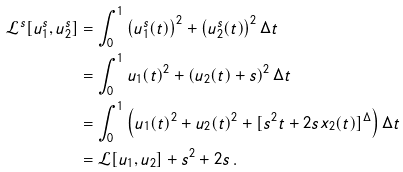<formula> <loc_0><loc_0><loc_500><loc_500>\mathcal { L } ^ { s } [ u _ { 1 } ^ { s } , u _ { 2 } ^ { s } ] & = \int _ { 0 } ^ { 1 } \left ( u _ { 1 } ^ { s } ( t ) \right ) ^ { 2 } + \left ( u _ { 2 } ^ { s } ( t ) \right ) ^ { 2 } \Delta t \\ & = \int _ { 0 } ^ { 1 } u _ { 1 } ( t ) ^ { 2 } + \left ( u _ { 2 } ( t ) + s \right ) ^ { 2 } \Delta t \\ & = \int _ { 0 } ^ { 1 } \left ( u _ { 1 } ( t ) ^ { 2 } + u _ { 2 } ( t ) ^ { 2 } + [ s ^ { 2 } t + 2 s x _ { 2 } ( t ) ] ^ { \Delta } \right ) \Delta t \\ & = \mathcal { L } [ u _ { 1 } , u _ { 2 } ] + s ^ { 2 } + 2 s \, .</formula> 